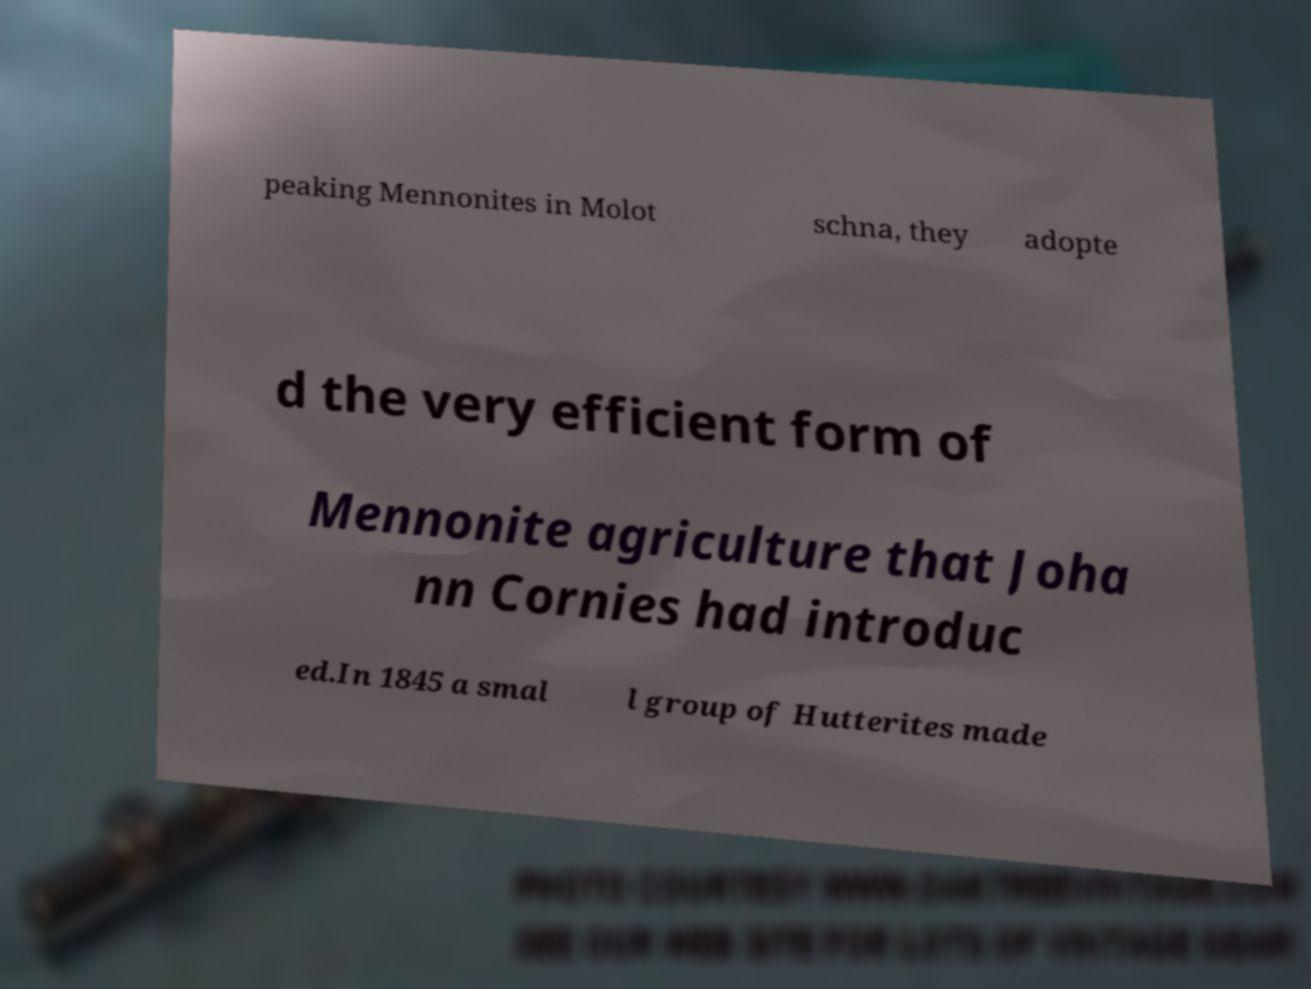I need the written content from this picture converted into text. Can you do that? peaking Mennonites in Molot schna, they adopte d the very efficient form of Mennonite agriculture that Joha nn Cornies had introduc ed.In 1845 a smal l group of Hutterites made 